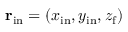Convert formula to latex. <formula><loc_0><loc_0><loc_500><loc_500>{ r } _ { i n } = ( x _ { i n } , y _ { i n } , z _ { f } )</formula> 